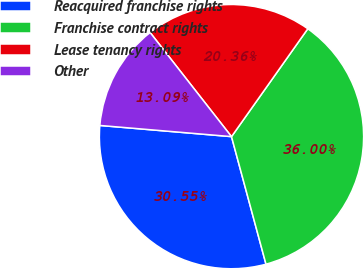Convert chart to OTSL. <chart><loc_0><loc_0><loc_500><loc_500><pie_chart><fcel>Reacquired franchise rights<fcel>Franchise contract rights<fcel>Lease tenancy rights<fcel>Other<nl><fcel>30.55%<fcel>36.0%<fcel>20.36%<fcel>13.09%<nl></chart> 